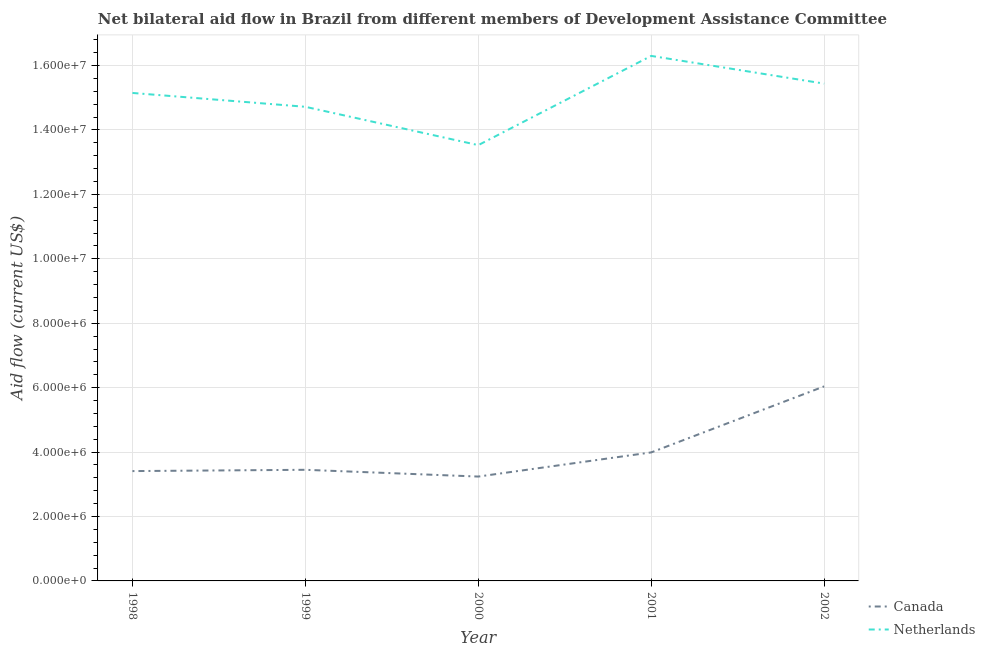How many different coloured lines are there?
Ensure brevity in your answer.  2. Does the line corresponding to amount of aid given by canada intersect with the line corresponding to amount of aid given by netherlands?
Make the answer very short. No. Is the number of lines equal to the number of legend labels?
Offer a very short reply. Yes. What is the amount of aid given by canada in 1998?
Your answer should be very brief. 3.41e+06. Across all years, what is the maximum amount of aid given by netherlands?
Your answer should be compact. 1.63e+07. Across all years, what is the minimum amount of aid given by netherlands?
Your response must be concise. 1.35e+07. In which year was the amount of aid given by netherlands maximum?
Offer a very short reply. 2001. What is the total amount of aid given by netherlands in the graph?
Provide a short and direct response. 7.51e+07. What is the difference between the amount of aid given by netherlands in 1998 and that in 1999?
Provide a short and direct response. 4.30e+05. What is the difference between the amount of aid given by canada in 1999 and the amount of aid given by netherlands in 1998?
Give a very brief answer. -1.17e+07. What is the average amount of aid given by netherlands per year?
Make the answer very short. 1.50e+07. In the year 1999, what is the difference between the amount of aid given by netherlands and amount of aid given by canada?
Your answer should be very brief. 1.13e+07. What is the ratio of the amount of aid given by canada in 1999 to that in 2000?
Keep it short and to the point. 1.06. Is the difference between the amount of aid given by netherlands in 1999 and 2002 greater than the difference between the amount of aid given by canada in 1999 and 2002?
Provide a short and direct response. Yes. What is the difference between the highest and the second highest amount of aid given by netherlands?
Your response must be concise. 8.60e+05. What is the difference between the highest and the lowest amount of aid given by canada?
Your answer should be compact. 2.80e+06. In how many years, is the amount of aid given by netherlands greater than the average amount of aid given by netherlands taken over all years?
Make the answer very short. 3. Is the sum of the amount of aid given by canada in 1998 and 2000 greater than the maximum amount of aid given by netherlands across all years?
Give a very brief answer. No. Does the amount of aid given by netherlands monotonically increase over the years?
Offer a terse response. No. Is the amount of aid given by canada strictly greater than the amount of aid given by netherlands over the years?
Offer a very short reply. No. How many lines are there?
Provide a short and direct response. 2. What is the difference between two consecutive major ticks on the Y-axis?
Provide a succinct answer. 2.00e+06. Are the values on the major ticks of Y-axis written in scientific E-notation?
Your response must be concise. Yes. Does the graph contain grids?
Make the answer very short. Yes. Where does the legend appear in the graph?
Your answer should be very brief. Bottom right. How many legend labels are there?
Ensure brevity in your answer.  2. What is the title of the graph?
Offer a very short reply. Net bilateral aid flow in Brazil from different members of Development Assistance Committee. What is the Aid flow (current US$) of Canada in 1998?
Keep it short and to the point. 3.41e+06. What is the Aid flow (current US$) of Netherlands in 1998?
Offer a very short reply. 1.52e+07. What is the Aid flow (current US$) of Canada in 1999?
Give a very brief answer. 3.45e+06. What is the Aid flow (current US$) of Netherlands in 1999?
Provide a short and direct response. 1.47e+07. What is the Aid flow (current US$) in Canada in 2000?
Provide a short and direct response. 3.24e+06. What is the Aid flow (current US$) of Netherlands in 2000?
Offer a terse response. 1.35e+07. What is the Aid flow (current US$) in Canada in 2001?
Your answer should be compact. 3.99e+06. What is the Aid flow (current US$) in Netherlands in 2001?
Offer a very short reply. 1.63e+07. What is the Aid flow (current US$) of Canada in 2002?
Provide a succinct answer. 6.04e+06. What is the Aid flow (current US$) of Netherlands in 2002?
Your answer should be very brief. 1.54e+07. Across all years, what is the maximum Aid flow (current US$) in Canada?
Ensure brevity in your answer.  6.04e+06. Across all years, what is the maximum Aid flow (current US$) in Netherlands?
Your answer should be compact. 1.63e+07. Across all years, what is the minimum Aid flow (current US$) of Canada?
Offer a terse response. 3.24e+06. Across all years, what is the minimum Aid flow (current US$) of Netherlands?
Ensure brevity in your answer.  1.35e+07. What is the total Aid flow (current US$) of Canada in the graph?
Provide a succinct answer. 2.01e+07. What is the total Aid flow (current US$) in Netherlands in the graph?
Offer a terse response. 7.51e+07. What is the difference between the Aid flow (current US$) of Netherlands in 1998 and that in 1999?
Your answer should be compact. 4.30e+05. What is the difference between the Aid flow (current US$) of Canada in 1998 and that in 2000?
Provide a short and direct response. 1.70e+05. What is the difference between the Aid flow (current US$) of Netherlands in 1998 and that in 2000?
Your answer should be compact. 1.62e+06. What is the difference between the Aid flow (current US$) in Canada in 1998 and that in 2001?
Your answer should be very brief. -5.80e+05. What is the difference between the Aid flow (current US$) of Netherlands in 1998 and that in 2001?
Offer a very short reply. -1.15e+06. What is the difference between the Aid flow (current US$) in Canada in 1998 and that in 2002?
Keep it short and to the point. -2.63e+06. What is the difference between the Aid flow (current US$) of Netherlands in 1998 and that in 2002?
Offer a very short reply. -2.90e+05. What is the difference between the Aid flow (current US$) of Netherlands in 1999 and that in 2000?
Ensure brevity in your answer.  1.19e+06. What is the difference between the Aid flow (current US$) of Canada in 1999 and that in 2001?
Your answer should be very brief. -5.40e+05. What is the difference between the Aid flow (current US$) in Netherlands in 1999 and that in 2001?
Your answer should be very brief. -1.58e+06. What is the difference between the Aid flow (current US$) in Canada in 1999 and that in 2002?
Offer a terse response. -2.59e+06. What is the difference between the Aid flow (current US$) in Netherlands in 1999 and that in 2002?
Keep it short and to the point. -7.20e+05. What is the difference between the Aid flow (current US$) in Canada in 2000 and that in 2001?
Provide a short and direct response. -7.50e+05. What is the difference between the Aid flow (current US$) of Netherlands in 2000 and that in 2001?
Offer a terse response. -2.77e+06. What is the difference between the Aid flow (current US$) in Canada in 2000 and that in 2002?
Give a very brief answer. -2.80e+06. What is the difference between the Aid flow (current US$) of Netherlands in 2000 and that in 2002?
Ensure brevity in your answer.  -1.91e+06. What is the difference between the Aid flow (current US$) in Canada in 2001 and that in 2002?
Keep it short and to the point. -2.05e+06. What is the difference between the Aid flow (current US$) of Netherlands in 2001 and that in 2002?
Make the answer very short. 8.60e+05. What is the difference between the Aid flow (current US$) in Canada in 1998 and the Aid flow (current US$) in Netherlands in 1999?
Ensure brevity in your answer.  -1.13e+07. What is the difference between the Aid flow (current US$) of Canada in 1998 and the Aid flow (current US$) of Netherlands in 2000?
Provide a short and direct response. -1.01e+07. What is the difference between the Aid flow (current US$) of Canada in 1998 and the Aid flow (current US$) of Netherlands in 2001?
Offer a very short reply. -1.29e+07. What is the difference between the Aid flow (current US$) of Canada in 1998 and the Aid flow (current US$) of Netherlands in 2002?
Ensure brevity in your answer.  -1.20e+07. What is the difference between the Aid flow (current US$) in Canada in 1999 and the Aid flow (current US$) in Netherlands in 2000?
Ensure brevity in your answer.  -1.01e+07. What is the difference between the Aid flow (current US$) in Canada in 1999 and the Aid flow (current US$) in Netherlands in 2001?
Give a very brief answer. -1.28e+07. What is the difference between the Aid flow (current US$) in Canada in 1999 and the Aid flow (current US$) in Netherlands in 2002?
Ensure brevity in your answer.  -1.20e+07. What is the difference between the Aid flow (current US$) in Canada in 2000 and the Aid flow (current US$) in Netherlands in 2001?
Offer a very short reply. -1.31e+07. What is the difference between the Aid flow (current US$) in Canada in 2000 and the Aid flow (current US$) in Netherlands in 2002?
Your answer should be very brief. -1.22e+07. What is the difference between the Aid flow (current US$) in Canada in 2001 and the Aid flow (current US$) in Netherlands in 2002?
Provide a succinct answer. -1.14e+07. What is the average Aid flow (current US$) in Canada per year?
Provide a succinct answer. 4.03e+06. What is the average Aid flow (current US$) in Netherlands per year?
Offer a terse response. 1.50e+07. In the year 1998, what is the difference between the Aid flow (current US$) in Canada and Aid flow (current US$) in Netherlands?
Offer a terse response. -1.17e+07. In the year 1999, what is the difference between the Aid flow (current US$) of Canada and Aid flow (current US$) of Netherlands?
Your response must be concise. -1.13e+07. In the year 2000, what is the difference between the Aid flow (current US$) in Canada and Aid flow (current US$) in Netherlands?
Provide a short and direct response. -1.03e+07. In the year 2001, what is the difference between the Aid flow (current US$) in Canada and Aid flow (current US$) in Netherlands?
Your answer should be compact. -1.23e+07. In the year 2002, what is the difference between the Aid flow (current US$) of Canada and Aid flow (current US$) of Netherlands?
Keep it short and to the point. -9.40e+06. What is the ratio of the Aid flow (current US$) in Canada in 1998 to that in 1999?
Give a very brief answer. 0.99. What is the ratio of the Aid flow (current US$) of Netherlands in 1998 to that in 1999?
Offer a very short reply. 1.03. What is the ratio of the Aid flow (current US$) of Canada in 1998 to that in 2000?
Your answer should be compact. 1.05. What is the ratio of the Aid flow (current US$) in Netherlands in 1998 to that in 2000?
Your response must be concise. 1.12. What is the ratio of the Aid flow (current US$) of Canada in 1998 to that in 2001?
Make the answer very short. 0.85. What is the ratio of the Aid flow (current US$) in Netherlands in 1998 to that in 2001?
Give a very brief answer. 0.93. What is the ratio of the Aid flow (current US$) in Canada in 1998 to that in 2002?
Ensure brevity in your answer.  0.56. What is the ratio of the Aid flow (current US$) in Netherlands in 1998 to that in 2002?
Ensure brevity in your answer.  0.98. What is the ratio of the Aid flow (current US$) of Canada in 1999 to that in 2000?
Offer a very short reply. 1.06. What is the ratio of the Aid flow (current US$) of Netherlands in 1999 to that in 2000?
Provide a succinct answer. 1.09. What is the ratio of the Aid flow (current US$) in Canada in 1999 to that in 2001?
Ensure brevity in your answer.  0.86. What is the ratio of the Aid flow (current US$) in Netherlands in 1999 to that in 2001?
Make the answer very short. 0.9. What is the ratio of the Aid flow (current US$) in Canada in 1999 to that in 2002?
Ensure brevity in your answer.  0.57. What is the ratio of the Aid flow (current US$) in Netherlands in 1999 to that in 2002?
Offer a terse response. 0.95. What is the ratio of the Aid flow (current US$) in Canada in 2000 to that in 2001?
Keep it short and to the point. 0.81. What is the ratio of the Aid flow (current US$) in Netherlands in 2000 to that in 2001?
Keep it short and to the point. 0.83. What is the ratio of the Aid flow (current US$) in Canada in 2000 to that in 2002?
Provide a succinct answer. 0.54. What is the ratio of the Aid flow (current US$) of Netherlands in 2000 to that in 2002?
Make the answer very short. 0.88. What is the ratio of the Aid flow (current US$) in Canada in 2001 to that in 2002?
Give a very brief answer. 0.66. What is the ratio of the Aid flow (current US$) in Netherlands in 2001 to that in 2002?
Give a very brief answer. 1.06. What is the difference between the highest and the second highest Aid flow (current US$) of Canada?
Offer a very short reply. 2.05e+06. What is the difference between the highest and the second highest Aid flow (current US$) in Netherlands?
Ensure brevity in your answer.  8.60e+05. What is the difference between the highest and the lowest Aid flow (current US$) of Canada?
Your answer should be compact. 2.80e+06. What is the difference between the highest and the lowest Aid flow (current US$) in Netherlands?
Your response must be concise. 2.77e+06. 